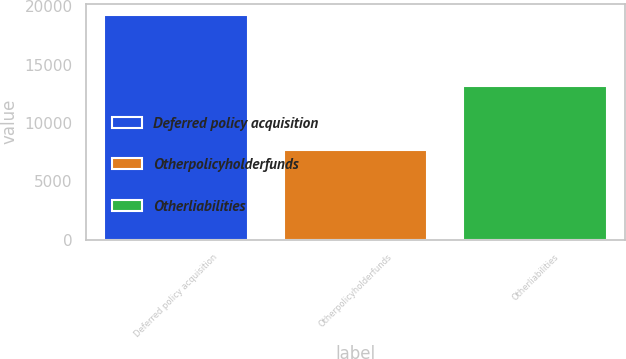Convert chart to OTSL. <chart><loc_0><loc_0><loc_500><loc_500><bar_chart><fcel>Deferred policy acquisition<fcel>Otherpolicyholderfunds<fcel>Otherliabilities<nl><fcel>19272<fcel>7695<fcel>13136<nl></chart> 